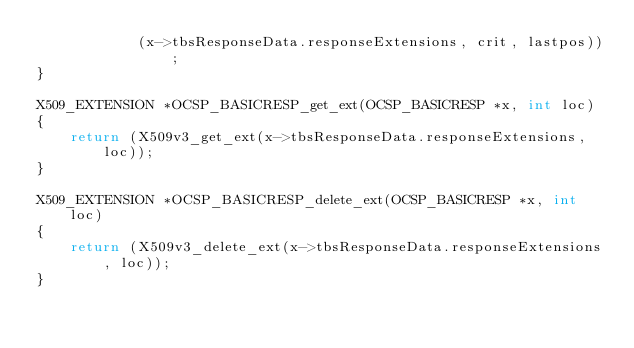Convert code to text. <code><loc_0><loc_0><loc_500><loc_500><_C_>            (x->tbsResponseData.responseExtensions, crit, lastpos));
}

X509_EXTENSION *OCSP_BASICRESP_get_ext(OCSP_BASICRESP *x, int loc)
{
    return (X509v3_get_ext(x->tbsResponseData.responseExtensions, loc));
}

X509_EXTENSION *OCSP_BASICRESP_delete_ext(OCSP_BASICRESP *x, int loc)
{
    return (X509v3_delete_ext(x->tbsResponseData.responseExtensions, loc));
}
</code> 